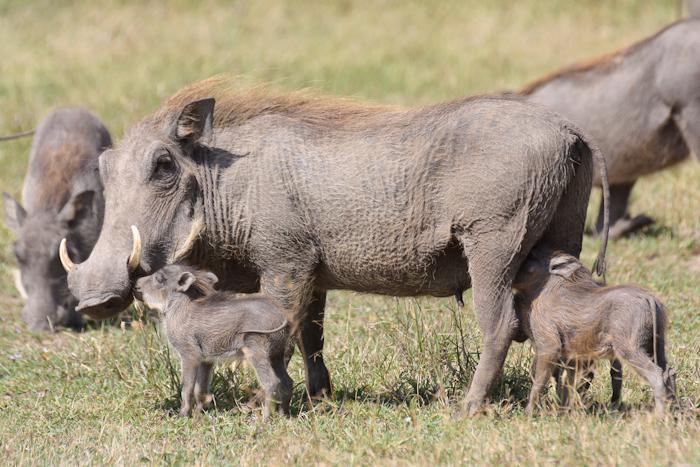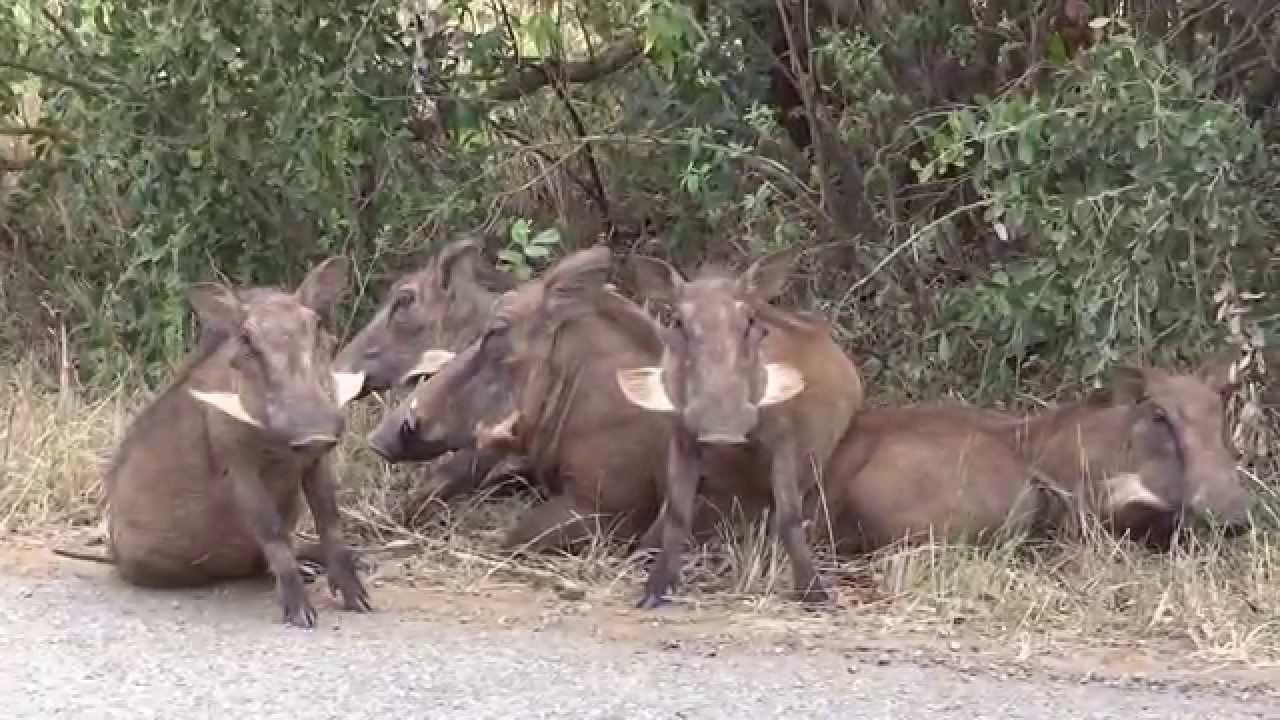The first image is the image on the left, the second image is the image on the right. Examine the images to the left and right. Is the description "An image shows at least four young warthogs and an adult moving along a wide dirt path flanked by grass." accurate? Answer yes or no. No. The first image is the image on the left, the second image is the image on the right. Assess this claim about the two images: "The right image contains exactly five warthogs.". Correct or not? Answer yes or no. Yes. 